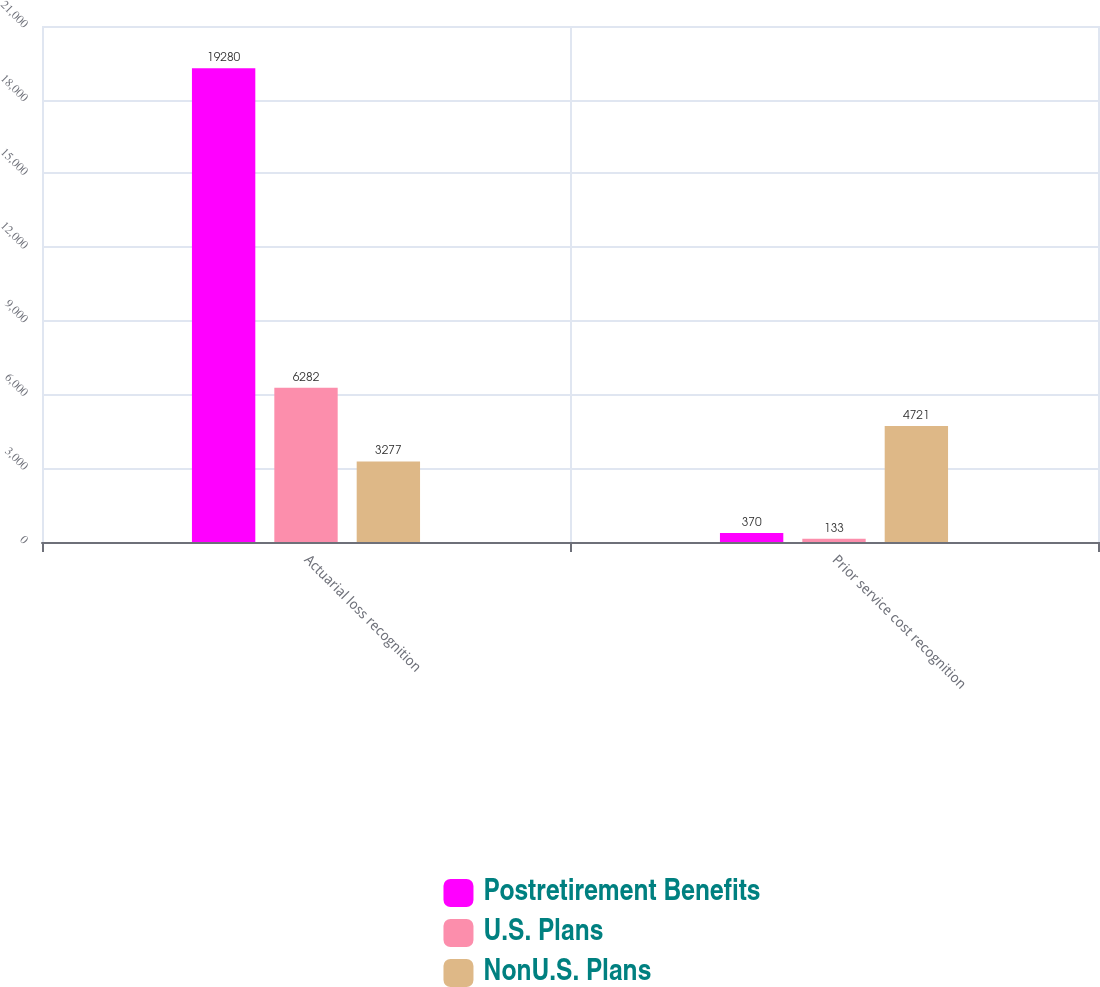<chart> <loc_0><loc_0><loc_500><loc_500><stacked_bar_chart><ecel><fcel>Actuarial loss recognition<fcel>Prior service cost recognition<nl><fcel>Postretirement Benefits<fcel>19280<fcel>370<nl><fcel>U.S. Plans<fcel>6282<fcel>133<nl><fcel>NonU.S. Plans<fcel>3277<fcel>4721<nl></chart> 